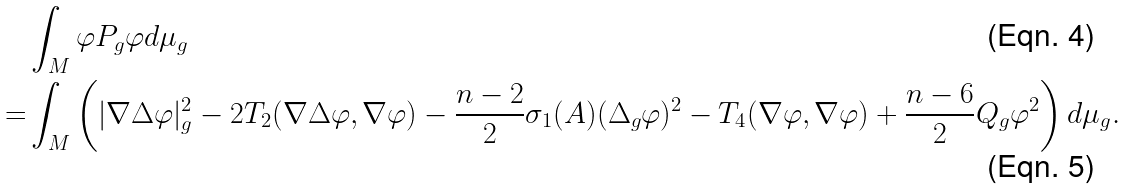Convert formula to latex. <formula><loc_0><loc_0><loc_500><loc_500>& \int _ { M } \varphi P _ { g } \varphi d \mu _ { g } \\ = & \int _ { M } \left ( | \nabla \Delta \varphi | _ { g } ^ { 2 } - 2 T _ { 2 } ( \nabla \Delta \varphi , \nabla \varphi ) - \frac { n - 2 } { 2 } \sigma _ { 1 } ( A ) ( \Delta _ { g } \varphi ) ^ { 2 } - T _ { 4 } ( \nabla \varphi , \nabla \varphi ) + \frac { n - 6 } { 2 } Q _ { g } \varphi ^ { 2 } \right ) d \mu _ { g } .</formula> 